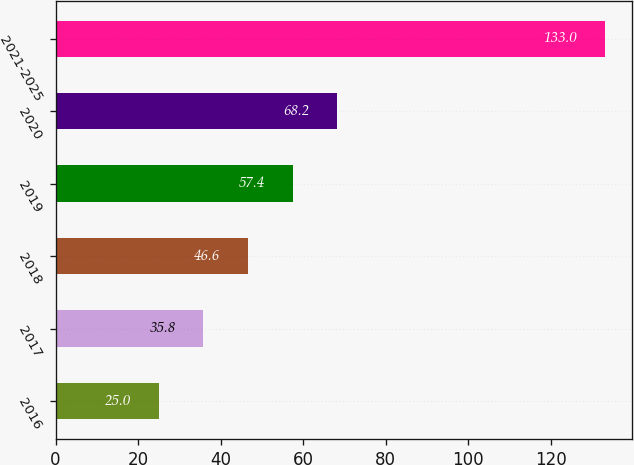Convert chart. <chart><loc_0><loc_0><loc_500><loc_500><bar_chart><fcel>2016<fcel>2017<fcel>2018<fcel>2019<fcel>2020<fcel>2021-2025<nl><fcel>25<fcel>35.8<fcel>46.6<fcel>57.4<fcel>68.2<fcel>133<nl></chart> 